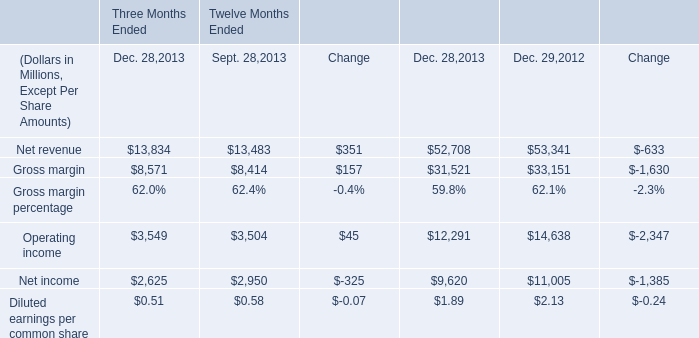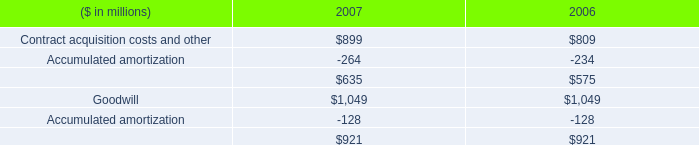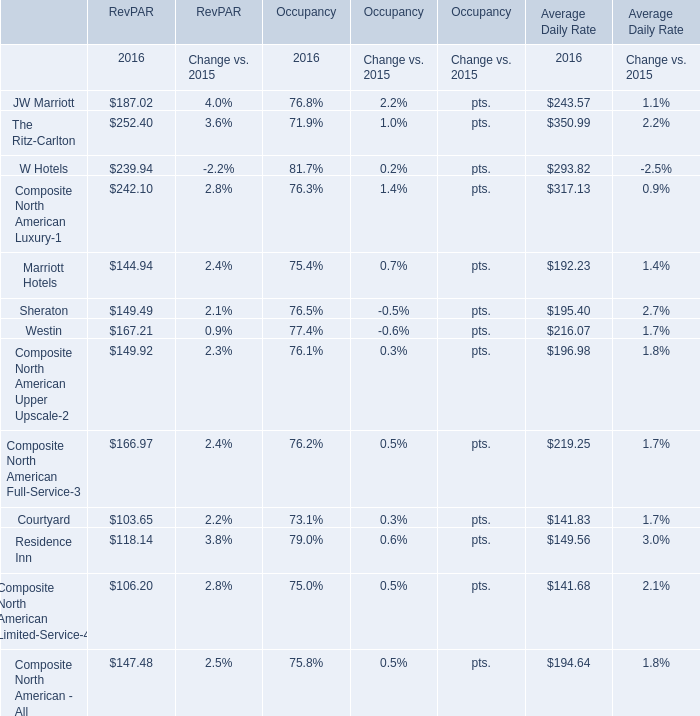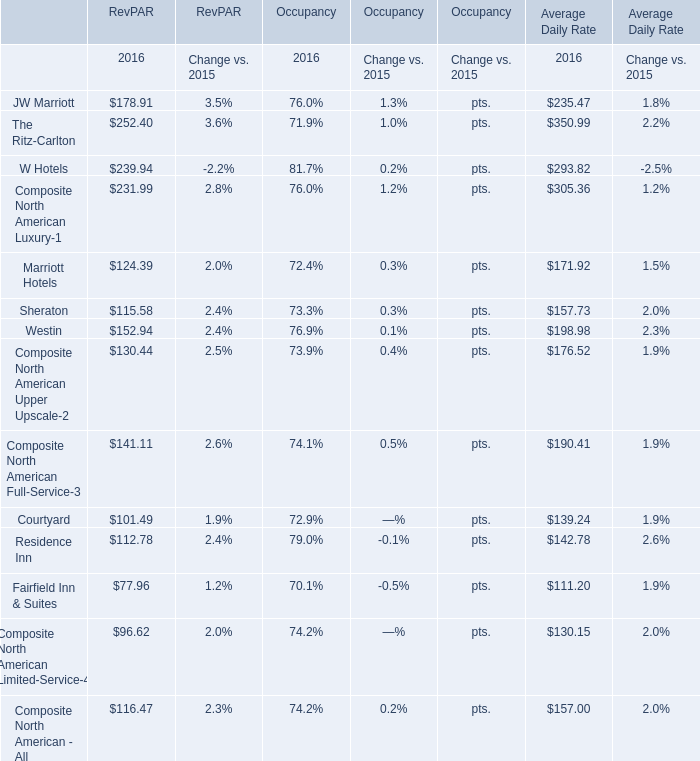What was the total amount of elements greater than 200 for RevPAR ? 
Computations: ((252.40 + 239.94) + 242.10)
Answer: 734.44. 